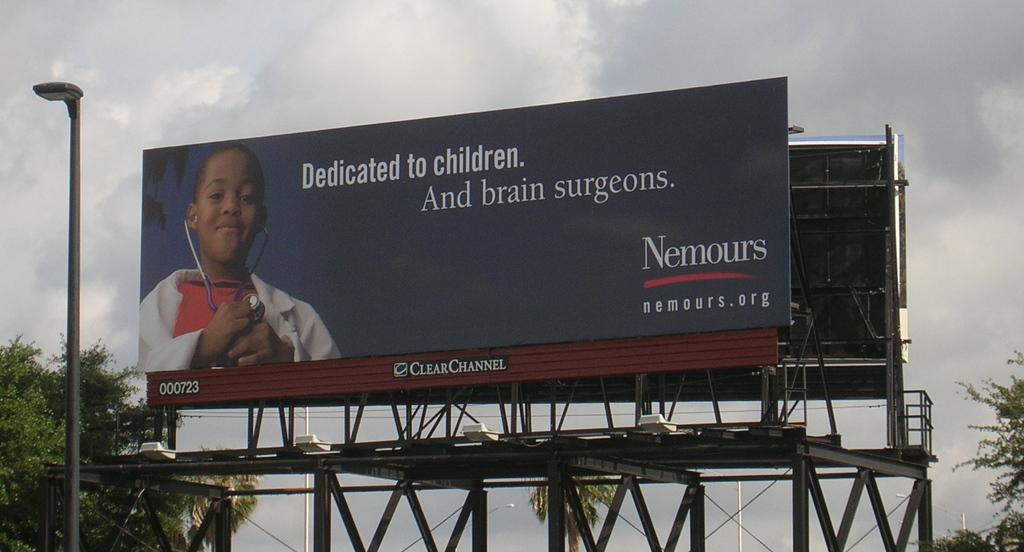<image>
Relay a brief, clear account of the picture shown. A billboard dedicated to the brain surgeons and patients for Nemours. 